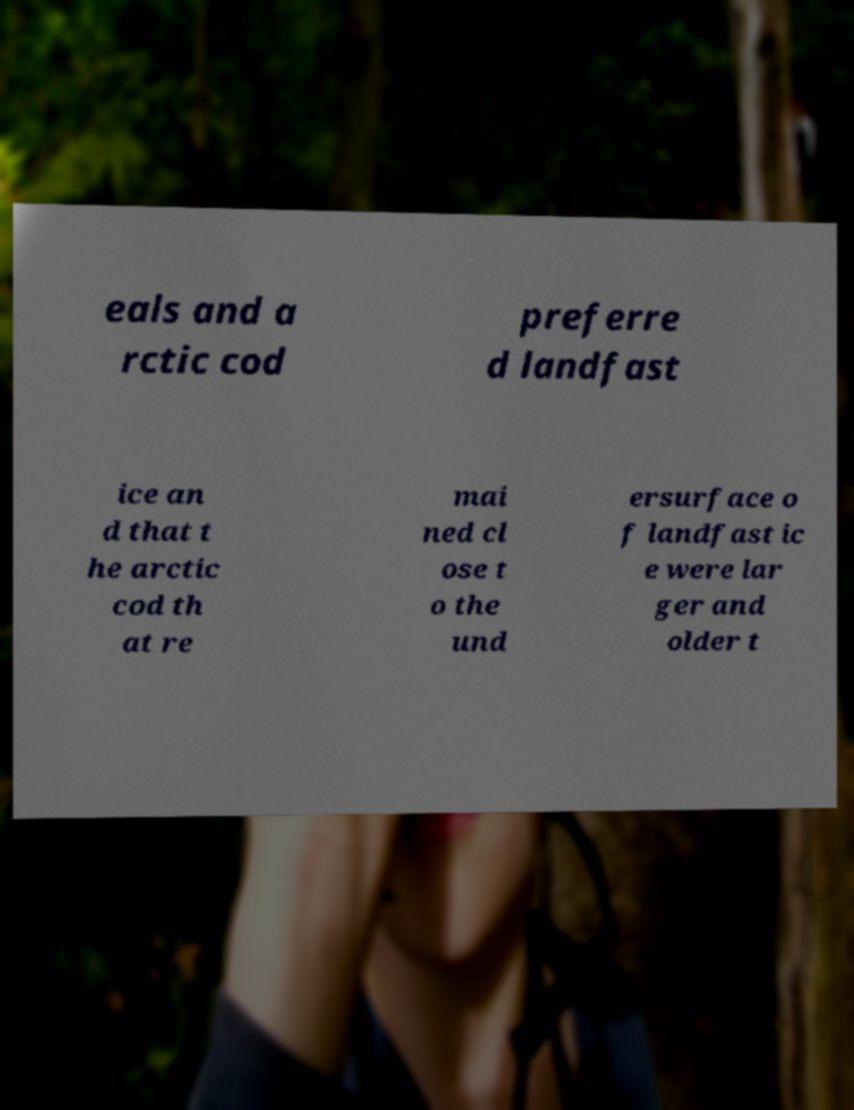There's text embedded in this image that I need extracted. Can you transcribe it verbatim? eals and a rctic cod preferre d landfast ice an d that t he arctic cod th at re mai ned cl ose t o the und ersurface o f landfast ic e were lar ger and older t 